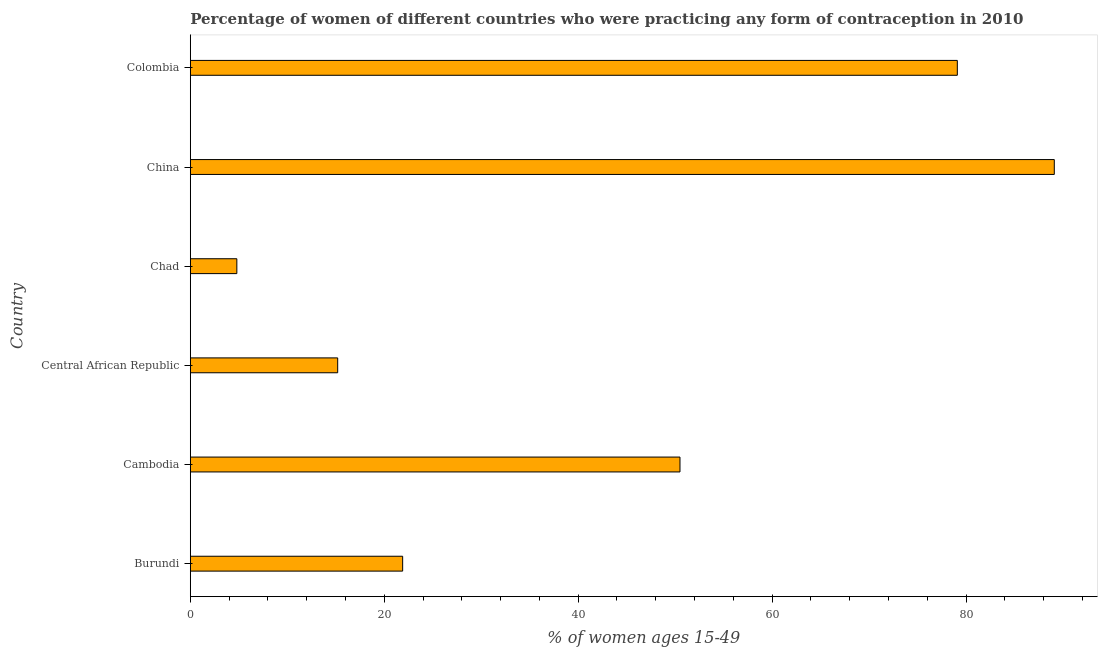Does the graph contain any zero values?
Offer a very short reply. No. What is the title of the graph?
Offer a very short reply. Percentage of women of different countries who were practicing any form of contraception in 2010. What is the label or title of the X-axis?
Offer a terse response. % of women ages 15-49. What is the contraceptive prevalence in Burundi?
Give a very brief answer. 21.9. Across all countries, what is the maximum contraceptive prevalence?
Give a very brief answer. 89.1. In which country was the contraceptive prevalence minimum?
Your answer should be very brief. Chad. What is the sum of the contraceptive prevalence?
Your answer should be very brief. 260.6. What is the difference between the contraceptive prevalence in Burundi and Colombia?
Your response must be concise. -57.2. What is the average contraceptive prevalence per country?
Offer a very short reply. 43.43. What is the median contraceptive prevalence?
Your answer should be very brief. 36.2. What is the ratio of the contraceptive prevalence in Central African Republic to that in Chad?
Provide a short and direct response. 3.17. Is the sum of the contraceptive prevalence in Burundi and Central African Republic greater than the maximum contraceptive prevalence across all countries?
Your answer should be very brief. No. What is the difference between the highest and the lowest contraceptive prevalence?
Offer a very short reply. 84.3. In how many countries, is the contraceptive prevalence greater than the average contraceptive prevalence taken over all countries?
Ensure brevity in your answer.  3. What is the difference between two consecutive major ticks on the X-axis?
Provide a short and direct response. 20. What is the % of women ages 15-49 in Burundi?
Ensure brevity in your answer.  21.9. What is the % of women ages 15-49 in Cambodia?
Your answer should be compact. 50.5. What is the % of women ages 15-49 of China?
Ensure brevity in your answer.  89.1. What is the % of women ages 15-49 of Colombia?
Your answer should be compact. 79.1. What is the difference between the % of women ages 15-49 in Burundi and Cambodia?
Provide a succinct answer. -28.6. What is the difference between the % of women ages 15-49 in Burundi and Central African Republic?
Your response must be concise. 6.7. What is the difference between the % of women ages 15-49 in Burundi and China?
Give a very brief answer. -67.2. What is the difference between the % of women ages 15-49 in Burundi and Colombia?
Give a very brief answer. -57.2. What is the difference between the % of women ages 15-49 in Cambodia and Central African Republic?
Provide a succinct answer. 35.3. What is the difference between the % of women ages 15-49 in Cambodia and Chad?
Your answer should be compact. 45.7. What is the difference between the % of women ages 15-49 in Cambodia and China?
Offer a very short reply. -38.6. What is the difference between the % of women ages 15-49 in Cambodia and Colombia?
Provide a short and direct response. -28.6. What is the difference between the % of women ages 15-49 in Central African Republic and Chad?
Make the answer very short. 10.4. What is the difference between the % of women ages 15-49 in Central African Republic and China?
Give a very brief answer. -73.9. What is the difference between the % of women ages 15-49 in Central African Republic and Colombia?
Your answer should be very brief. -63.9. What is the difference between the % of women ages 15-49 in Chad and China?
Keep it short and to the point. -84.3. What is the difference between the % of women ages 15-49 in Chad and Colombia?
Provide a short and direct response. -74.3. What is the difference between the % of women ages 15-49 in China and Colombia?
Offer a terse response. 10. What is the ratio of the % of women ages 15-49 in Burundi to that in Cambodia?
Your answer should be very brief. 0.43. What is the ratio of the % of women ages 15-49 in Burundi to that in Central African Republic?
Provide a succinct answer. 1.44. What is the ratio of the % of women ages 15-49 in Burundi to that in Chad?
Your answer should be very brief. 4.56. What is the ratio of the % of women ages 15-49 in Burundi to that in China?
Make the answer very short. 0.25. What is the ratio of the % of women ages 15-49 in Burundi to that in Colombia?
Make the answer very short. 0.28. What is the ratio of the % of women ages 15-49 in Cambodia to that in Central African Republic?
Your response must be concise. 3.32. What is the ratio of the % of women ages 15-49 in Cambodia to that in Chad?
Provide a succinct answer. 10.52. What is the ratio of the % of women ages 15-49 in Cambodia to that in China?
Your answer should be very brief. 0.57. What is the ratio of the % of women ages 15-49 in Cambodia to that in Colombia?
Your response must be concise. 0.64. What is the ratio of the % of women ages 15-49 in Central African Republic to that in Chad?
Make the answer very short. 3.17. What is the ratio of the % of women ages 15-49 in Central African Republic to that in China?
Your answer should be very brief. 0.17. What is the ratio of the % of women ages 15-49 in Central African Republic to that in Colombia?
Provide a short and direct response. 0.19. What is the ratio of the % of women ages 15-49 in Chad to that in China?
Your answer should be very brief. 0.05. What is the ratio of the % of women ages 15-49 in Chad to that in Colombia?
Provide a short and direct response. 0.06. What is the ratio of the % of women ages 15-49 in China to that in Colombia?
Provide a short and direct response. 1.13. 